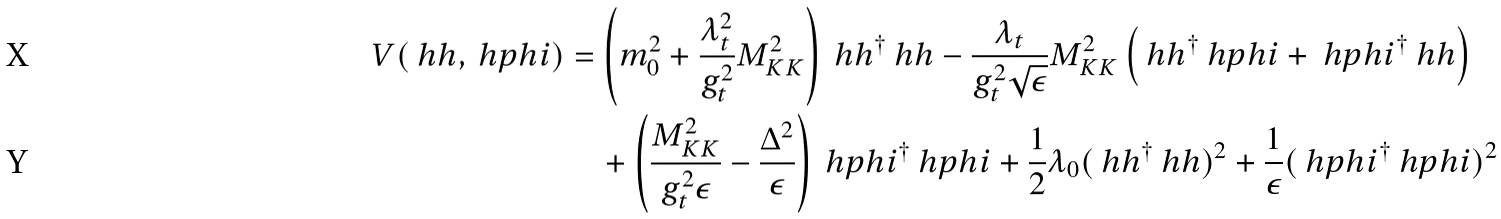<formula> <loc_0><loc_0><loc_500><loc_500>V ( \ h h , \ h p h i ) & = \left ( m _ { 0 } ^ { 2 } + \frac { \lambda ^ { 2 } _ { t } } { g _ { t } ^ { 2 } } M ^ { 2 } _ { K K } \right ) \ h h ^ { \dagger } \ h h - \frac { \lambda _ { t } } { g ^ { 2 } _ { t } \sqrt { \epsilon } } M _ { K K } ^ { 2 } \left ( \ h h ^ { \dagger } \ h p h i + \ h p h i ^ { \dagger } \ h h \right ) \\ & \quad + \left ( \frac { M _ { K K } ^ { 2 } } { g _ { t } ^ { 2 } \epsilon } - \frac { \Delta ^ { 2 } } { \epsilon } \right ) \ h p h i ^ { \dagger } \ h p h i + \frac { 1 } { 2 } \lambda _ { 0 } ( \ h h ^ { \dagger } \ h h ) ^ { 2 } + \frac { 1 } { \epsilon } ( \ h p h i ^ { \dagger } \ h p h i ) ^ { 2 }</formula> 